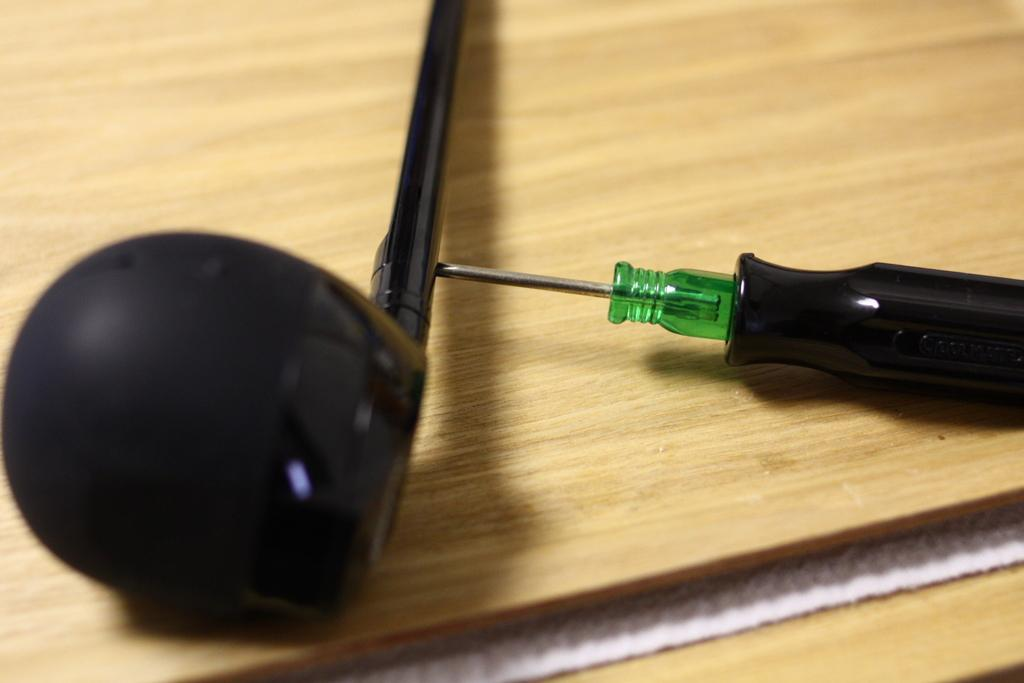What tool is visible in the image? There is a screwdriver in the image. What is the unspecified object on the table in the image? The facts do not provide any information about the object on the table, so we cannot answer this question definitively. What type of fork is being used by the aunt in the image? There is no aunt or fork present in the image. 